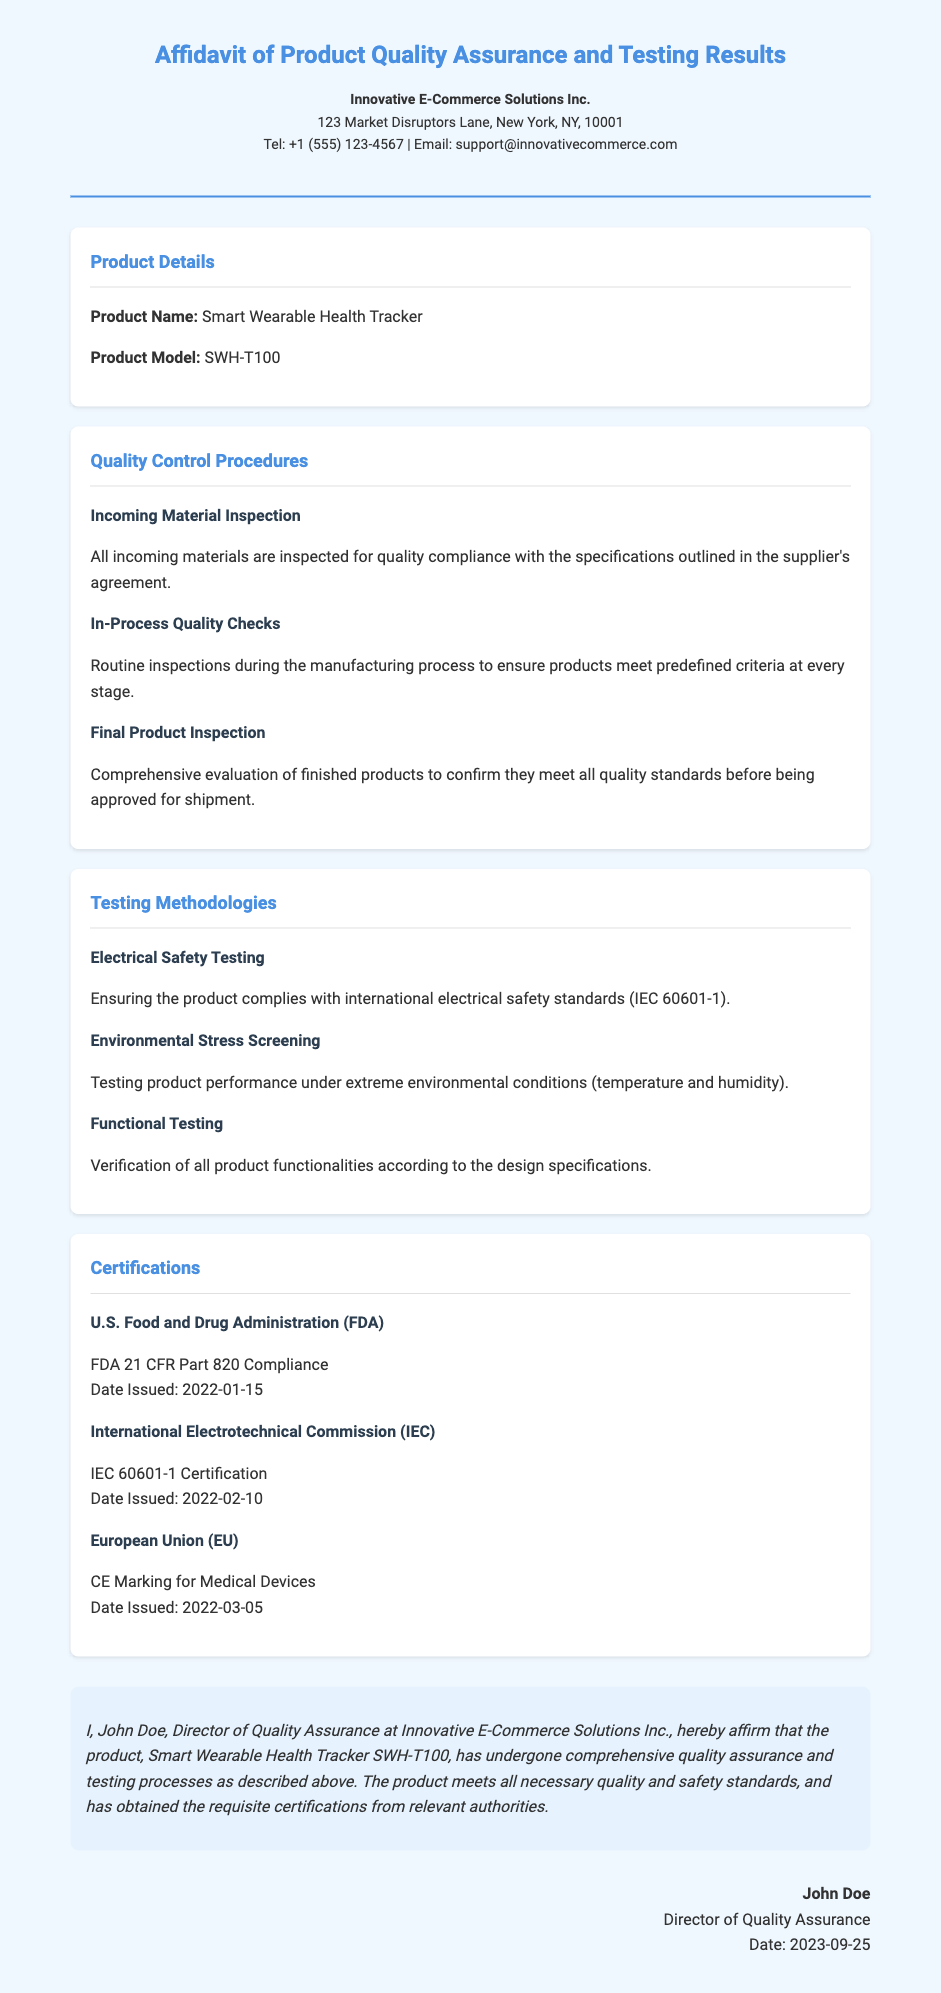What is the product name? The product name is explicitly stated in the document under "Product Details."
Answer: Smart Wearable Health Tracker Who is the Director of Quality Assurance? The document identifies the Director of Quality Assurance in the declaration section.
Answer: John Doe What certification did the product receive from the FDA? The FDA certification details are mentioned in the Certifications section.
Answer: FDA 21 CFR Part 820 Compliance When was the CE Marking for Medical Devices issued? The issuance date can be found under the Certifications section for the EU certification.
Answer: 2022-03-05 What is one of the quality control procedures mentioned? The document lists various quality control procedures under that section.
Answer: Incoming Material Inspection What standard does the Electrical Safety Testing comply with? The compliance standard is specified in the Testing Methodologies section.
Answer: IEC 60601-1 What date was the IEC certification issued? The issuance date is noted in the Certifications section.
Answer: 2022-02-10 What type of product is the Smart Wearable Health Tracker categorized as? The document implies this by providing certifications relevant to medical devices.
Answer: Medical Device 